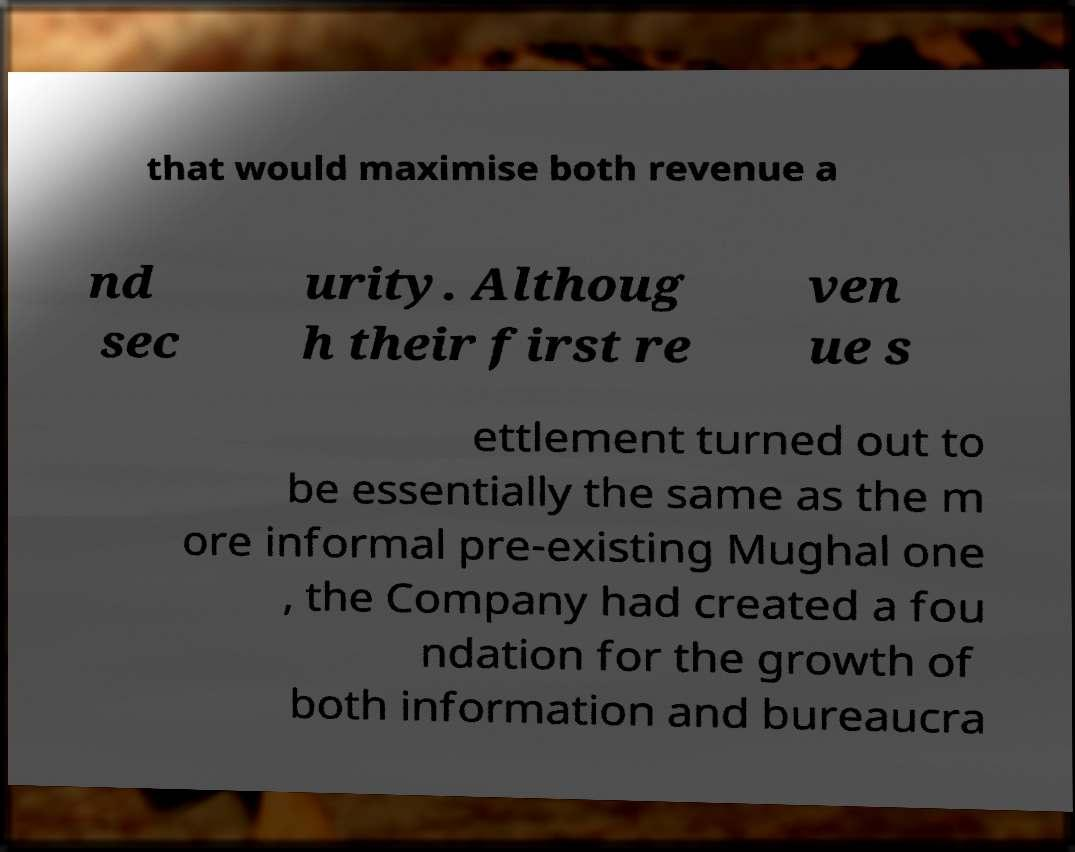Could you extract and type out the text from this image? that would maximise both revenue a nd sec urity. Althoug h their first re ven ue s ettlement turned out to be essentially the same as the m ore informal pre-existing Mughal one , the Company had created a fou ndation for the growth of both information and bureaucra 